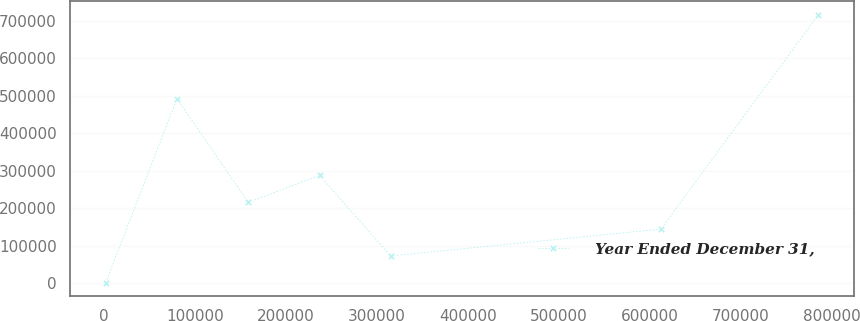<chart> <loc_0><loc_0><loc_500><loc_500><line_chart><ecel><fcel>Year Ended December 31,<nl><fcel>2155.42<fcel>1835.75<nl><fcel>80495.1<fcel>492470<nl><fcel>158835<fcel>216157<nl><fcel>237174<fcel>287598<nl><fcel>315514<fcel>73276.3<nl><fcel>612432<fcel>144717<nl><fcel>785552<fcel>716241<nl></chart> 